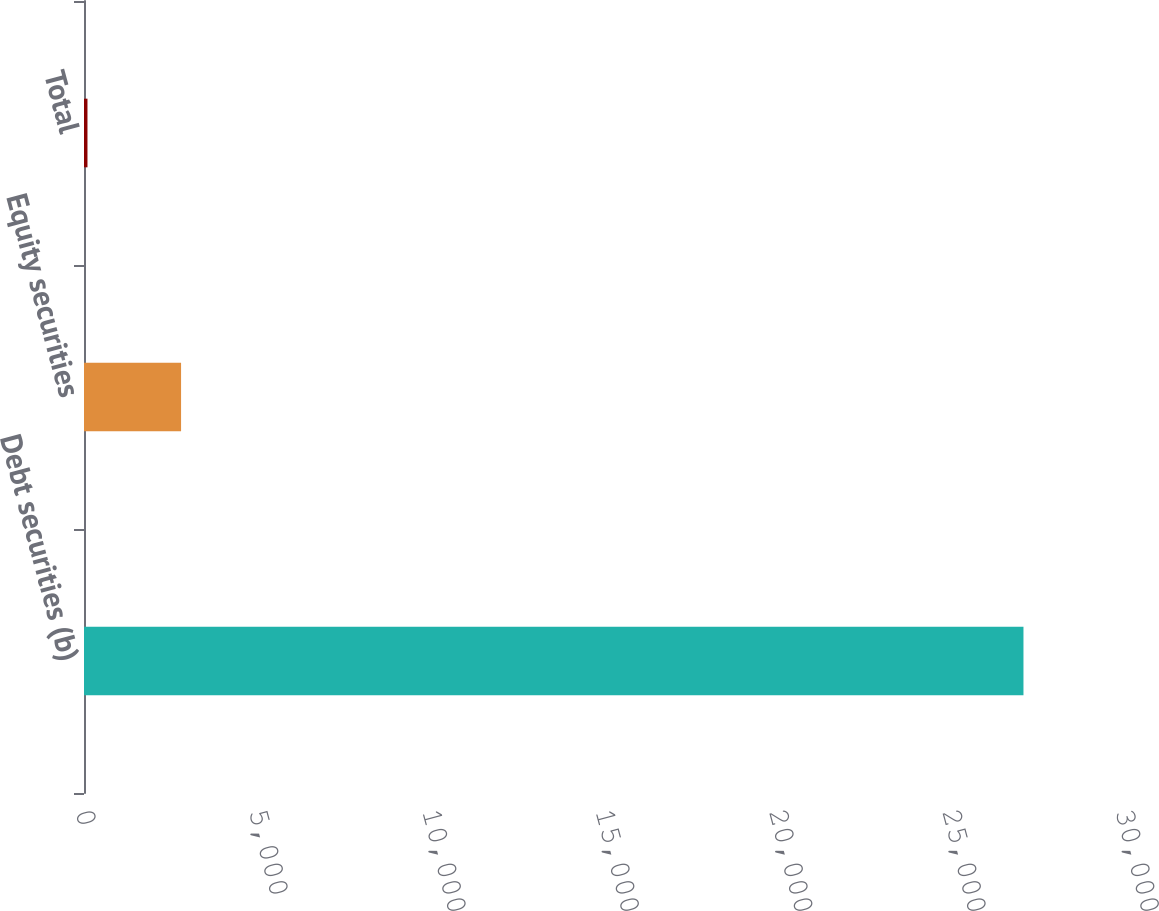Convert chart to OTSL. <chart><loc_0><loc_0><loc_500><loc_500><bar_chart><fcel>Debt securities (b)<fcel>Equity securities<fcel>Total<nl><fcel>27100<fcel>2800<fcel>100<nl></chart> 